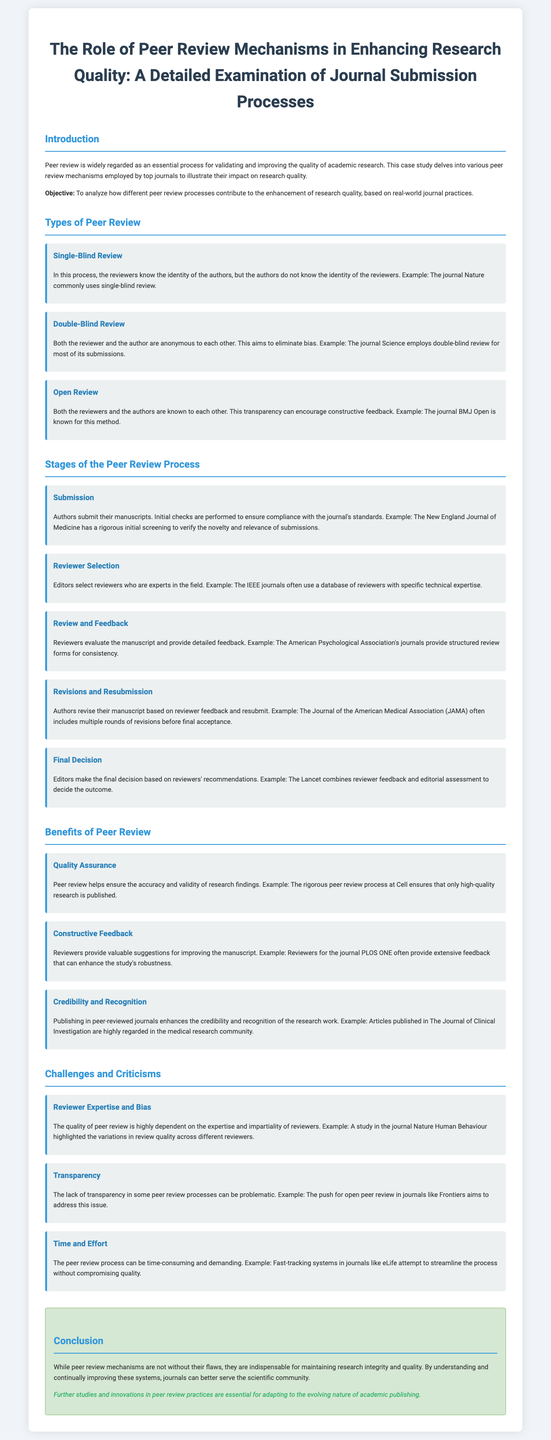What is the objective of the case study? The objective is to analyze how different peer review processes contribute to the enhancement of research quality, based on real-world journal practices.
Answer: To analyze how different peer review processes contribute to the enhancement of research quality, based on real-world journal practices Which peer review mechanism does the journal Nature commonly use? The document states that Nature commonly uses single-blind review.
Answer: Single-Blind Review What stage involves authors revising their manuscript based on reviewer feedback? This stage is referred to as "Revisions and Resubmission" in the document.
Answer: Revisions and Resubmission Which journal uses a double-blind review process? The document mentions that the journal Science employs double-blind review for most of its submissions.
Answer: Science What benefit of peer review ensures the accuracy of research findings? Quality assurance is identified as a benefit that helps ensure the accuracy and validity of research findings.
Answer: Quality Assurance What challenge is associated with reviewer expertise? The challenge related to reviewer expertise is described as "Reviewer Expertise and Bias" in the case study.
Answer: Reviewer Expertise and Bias How does peer review enhance the credibility of research work? The document explains that publishing in peer-reviewed journals enhances the credibility and recognition of the research work.
Answer: Enhances the credibility and recognition What type of review is known for its transparency? The document states that Open Review is known for transparency.
Answer: Open Review Which journal is noted for a rigorous initial screening of submissions? The New England Journal of Medicine is mentioned as having a rigorous initial screening to verify the novelty and relevance of submissions.
Answer: The New England Journal of Medicine 